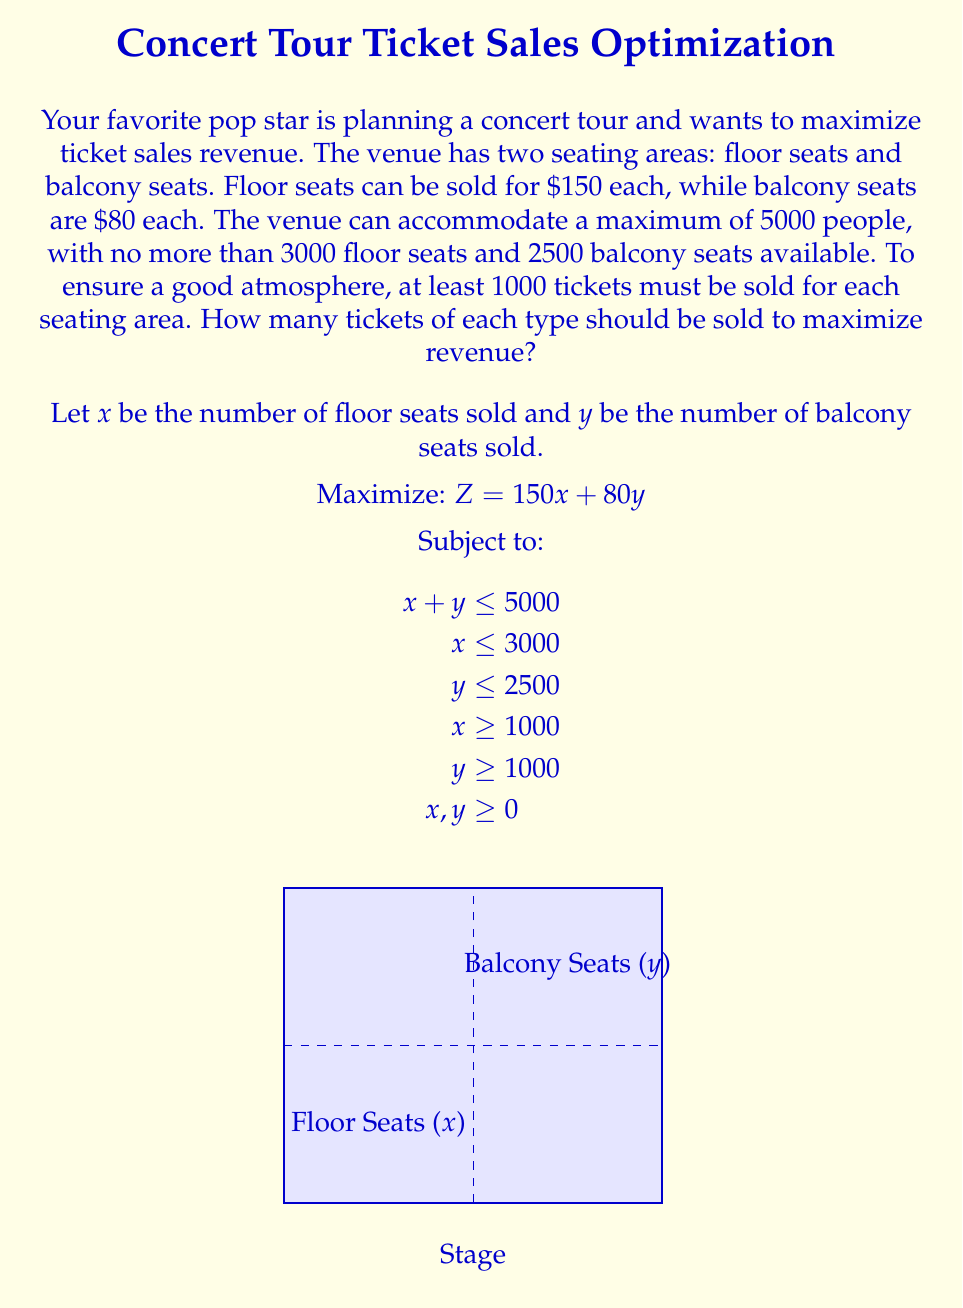Teach me how to tackle this problem. To solve this linear programming problem, we'll use the graphical method:

1) Plot the constraints:
   - $x + y = 5000$ (total capacity)
   - $x = 3000$ (max floor seats)
   - $y = 2500$ (max balcony seats)
   - $x = 1000$ (min floor seats)
   - $y = 1000$ (min balcony seats)

2) Identify the feasible region (the area that satisfies all constraints).

3) Find the corner points of the feasible region:
   A (1000, 1000)
   B (3000, 1000)
   C (3000, 2000)
   D (2500, 2500)

4) Evaluate the objective function $Z = 150x + 80y$ at each corner point:
   A: $Z = 150(1000) + 80(1000) = 230,000$
   B: $Z = 150(3000) + 80(1000) = 530,000$
   C: $Z = 150(3000) + 80(2000) = 610,000$
   D: $Z = 150(2500) + 80(2500) = 575,000$

5) The maximum value occurs at point C (3000, 2000).

Therefore, to maximize revenue, the pop star should sell 3000 floor seats and 2000 balcony seats.
Answer: 3000 floor seats, 2000 balcony seats 